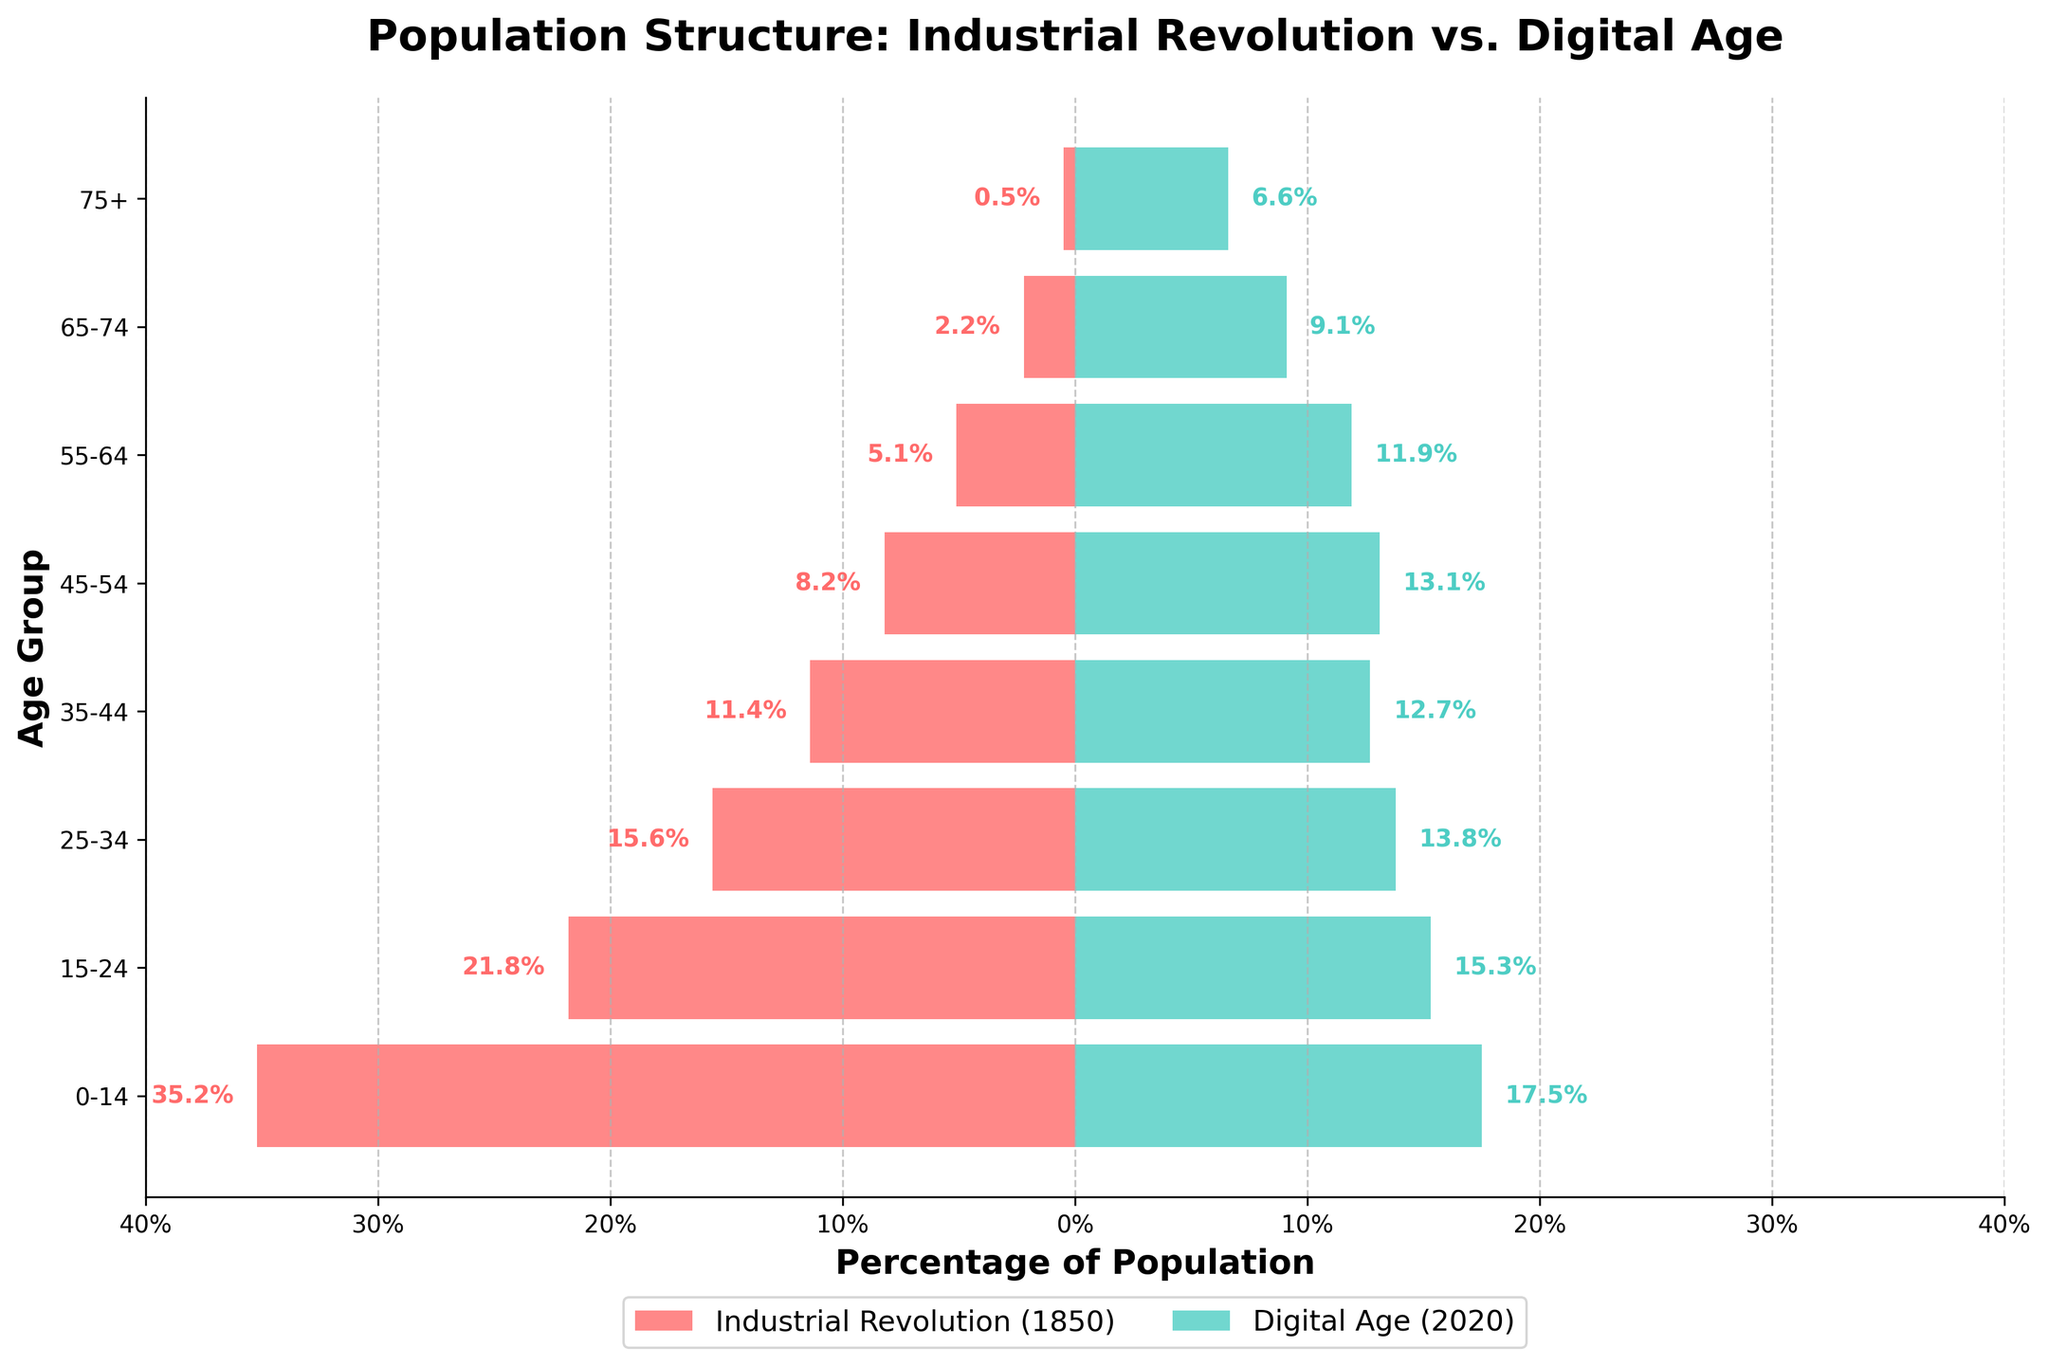What is the title of the figure? The title is prominently displayed at the top of the figure and reads "Population Structure: Industrial Revolution vs. Digital Age."
Answer: Population Structure: Industrial Revolution vs. Digital Age What is the age group with the highest percentage during the Industrial Revolution (1850)? By looking at the left side of the pyramid (the negative bars), the age group 0-14 has the highest percentage, which is 35.2%.
Answer: 0-14 Which age group has a higher percentage in the Digital Age (2020) compared to the Industrial Revolution (1850)? Comparing both sides of the pyramid, the age groups 45-54, 55-64, 65-74, and 75+ have higher percentages in 2020 compared to 1850.
Answer: 45-54, 55-64, 65-74, 75+ How does the population of the age group 25-34 in the Digital Age (2020) compare with that of the Industrial Revolution (1850)? On the right side, the age group 25-34 in 2020 has a percentage of 13.8%, whereas, on the left side, the same age group in 1850 has a percentage of 15.6%.
Answer: Lower What is the combined percentage of the population aged 55 and above in the Digital Age (2020)? Sum the percentages for age groups 55-64, 65-74, and 75+ in 2020: 11.9% + 9.1% + 6.6% = 27.6%.
Answer: 27.6% Which age group has the lowest percentage during the Industrial Revolution (1850)? Looking at the left side of the pyramid, the age group 75+ has the lowest percentage, which is 0.5%.
Answer: 75+ What is the difference in percentage points for the age group 15-24 between the Industrial Revolution (1850) and the Digital Age (2020)? Subtract the percentage of the Digital Age (15.3%) from that of the Industrial Revolution (21.8%): 21.8% - 15.3% = 6.5%.
Answer: 6.5 Which age group has nearly equal percentages in both the Industrial Revolution (1850) and the Digital Age (2020)? The age group 35-44 has percentages of 11.4% in 1850 and 12.7% in 2020, which are quite close to one another.
Answer: 35-44 What is the mean percentage of the age groups 0-14 and 15-24 in the Digital Age (2020)? Calculate the mean: (17.5% + 15.3%) / 2 = 16.4%.
Answer: 16.4% How does the population structure for the age group 75+ in 1850 compare to 2020? In 1850, the age group 75+ has a percentage of 0.5%, while in 2020, it has increased to 6.6%.
Answer: Increased 